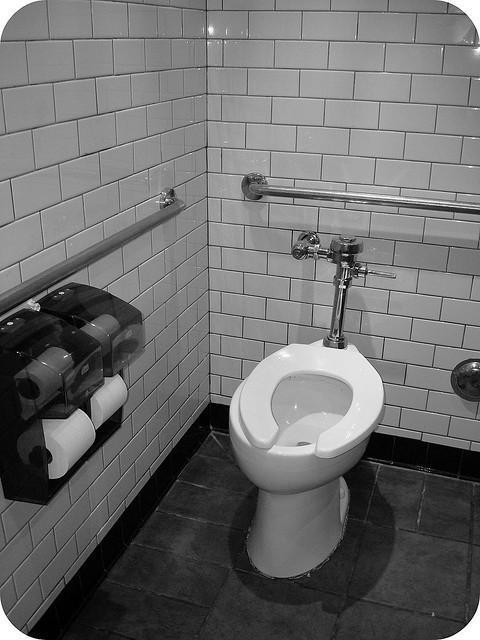How many rolls of toilet paper are there?
Give a very brief answer. 4. 